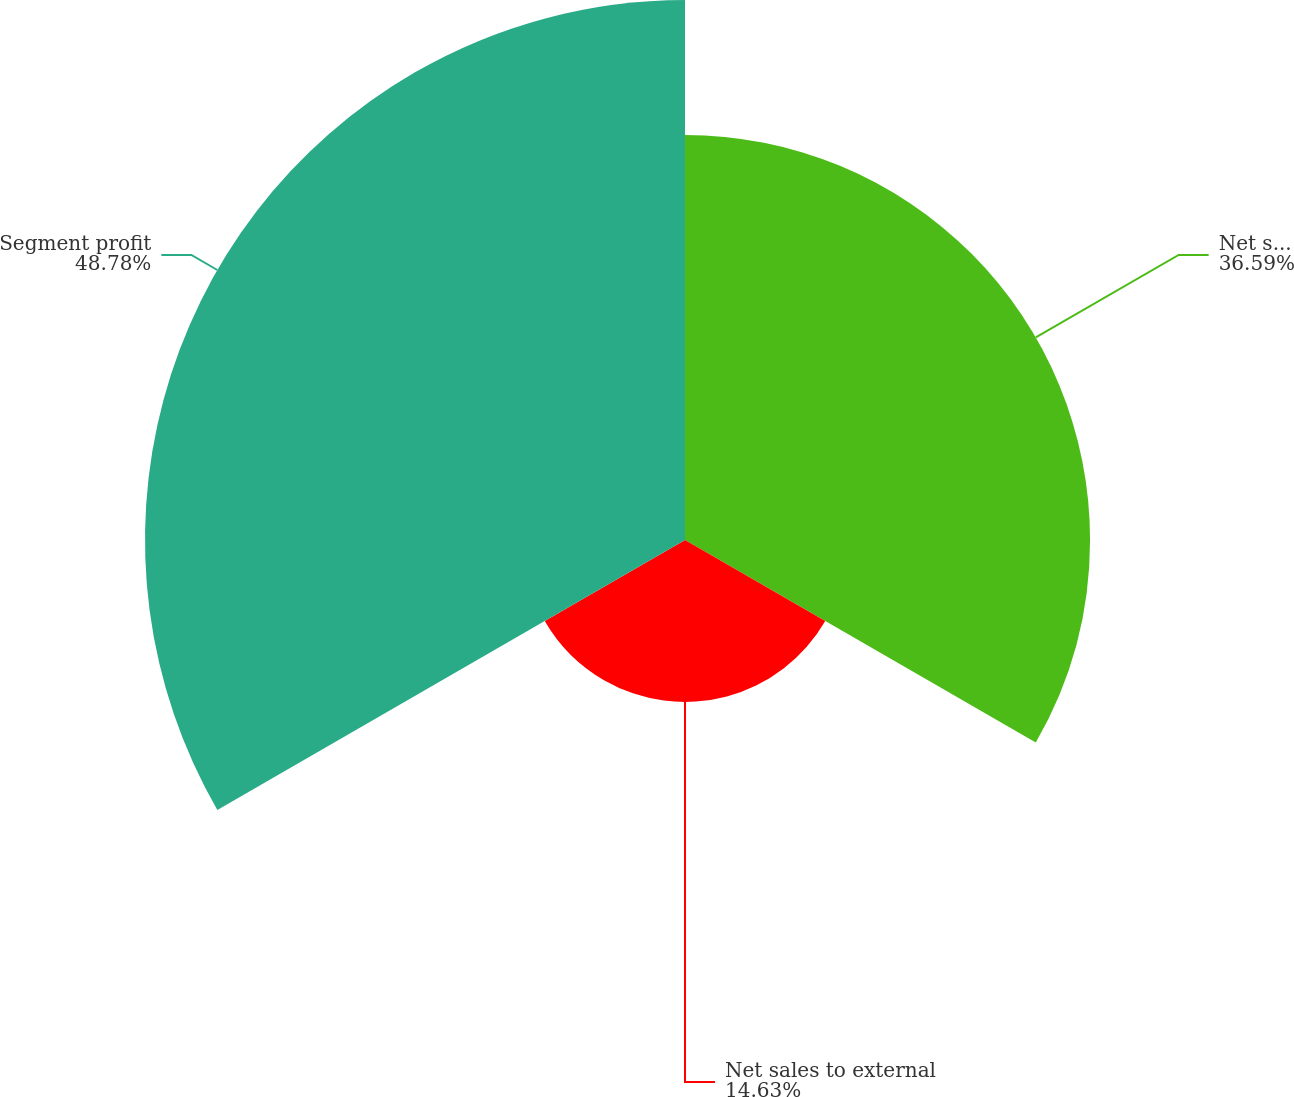Convert chart. <chart><loc_0><loc_0><loc_500><loc_500><pie_chart><fcel>Net sales<fcel>Net sales to external<fcel>Segment profit<nl><fcel>36.59%<fcel>14.63%<fcel>48.78%<nl></chart> 